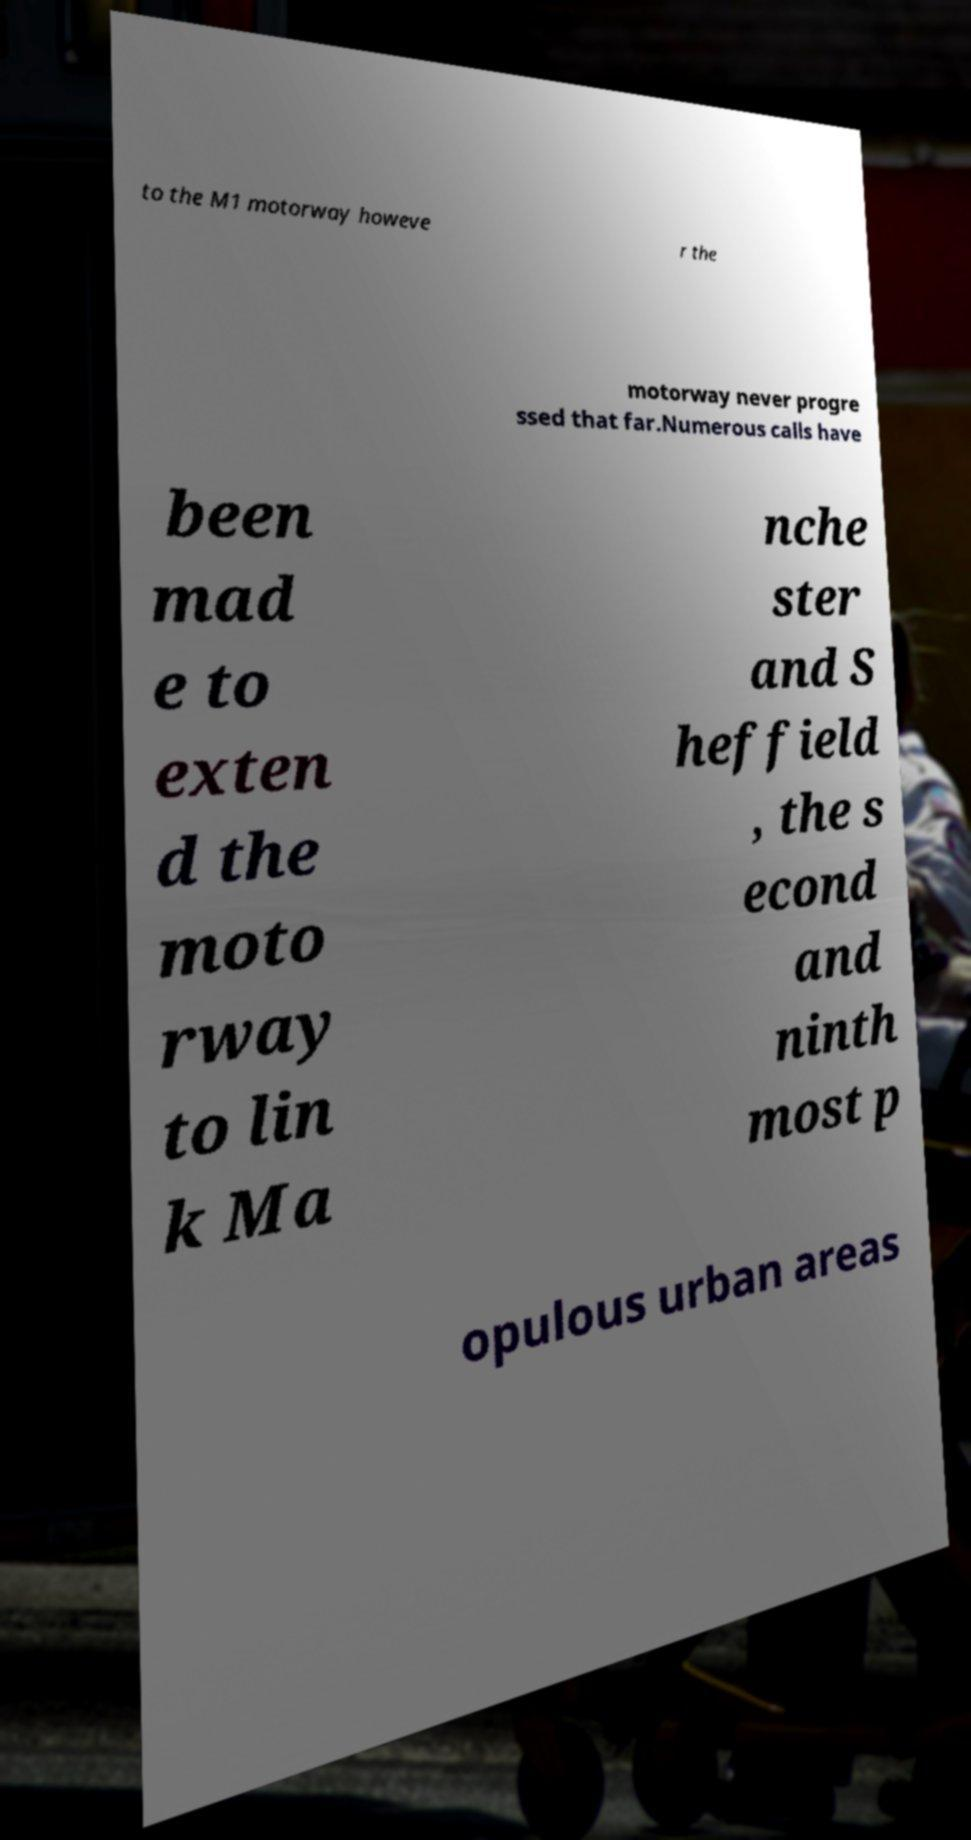Could you assist in decoding the text presented in this image and type it out clearly? to the M1 motorway howeve r the motorway never progre ssed that far.Numerous calls have been mad e to exten d the moto rway to lin k Ma nche ster and S heffield , the s econd and ninth most p opulous urban areas 